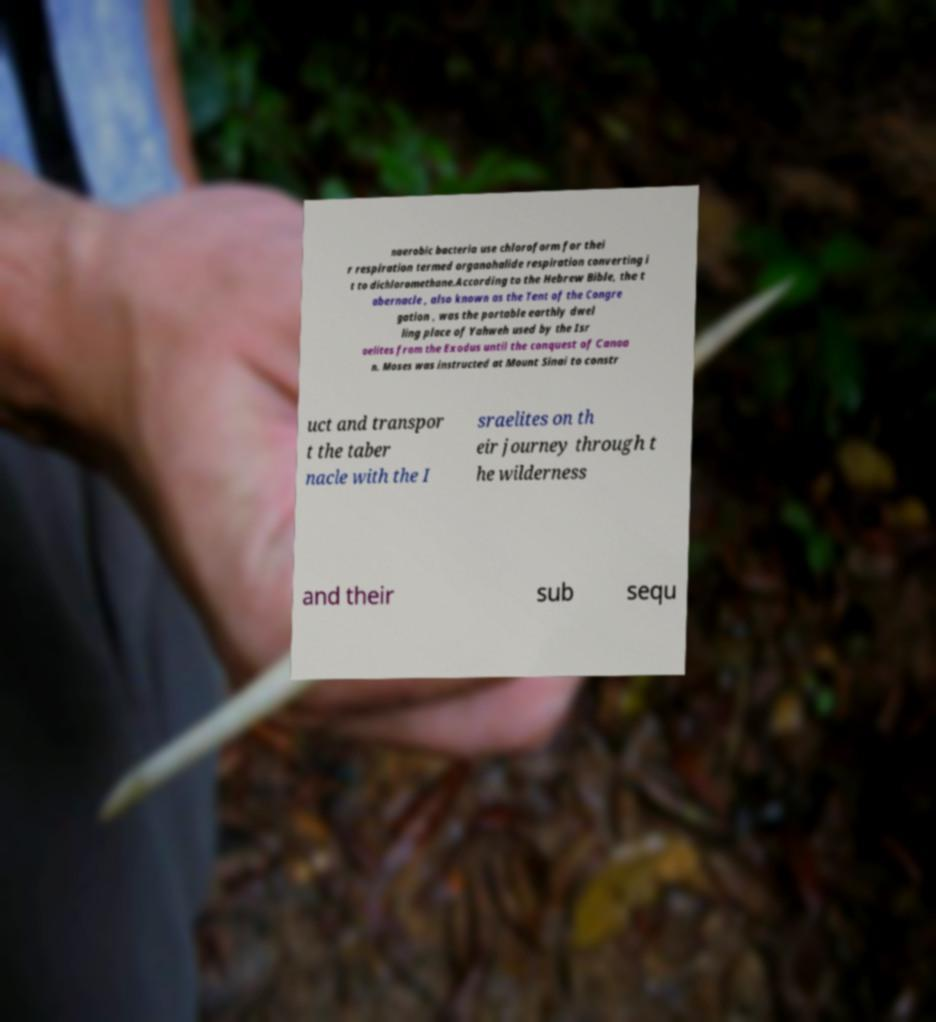What messages or text are displayed in this image? I need them in a readable, typed format. naerobic bacteria use chloroform for thei r respiration termed organohalide respiration converting i t to dichloromethane.According to the Hebrew Bible, the t abernacle , also known as the Tent of the Congre gation , was the portable earthly dwel ling place of Yahweh used by the Isr aelites from the Exodus until the conquest of Canaa n. Moses was instructed at Mount Sinai to constr uct and transpor t the taber nacle with the I sraelites on th eir journey through t he wilderness and their sub sequ 